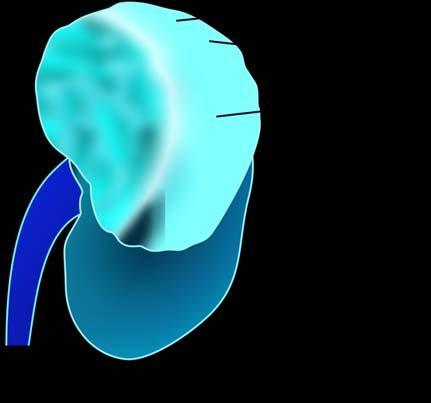what does the upper pole of the kidney show?
Answer the question using a single word or phrase. A large and tan mass 